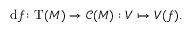Convert formula to latex. <formula><loc_0><loc_0><loc_500><loc_500>d f \colon T ( M ) \to { \mathcal { C } } ( M ) \colon V \mapsto V ( f ) .</formula> 